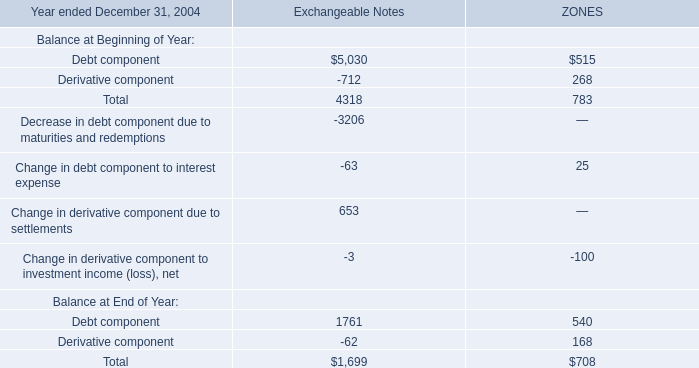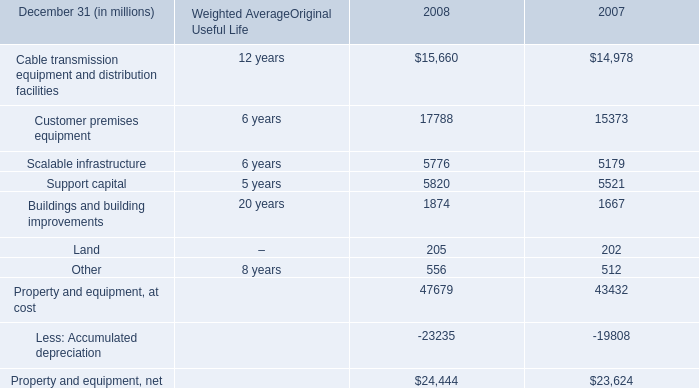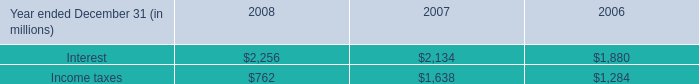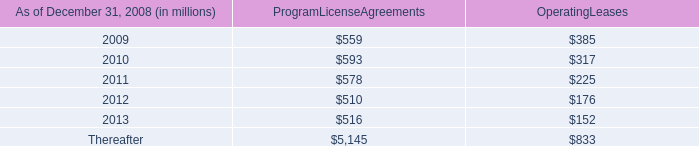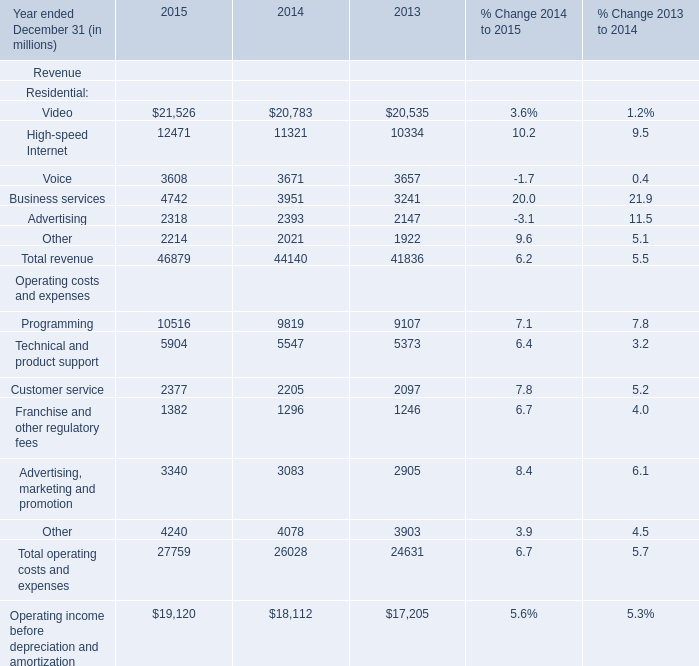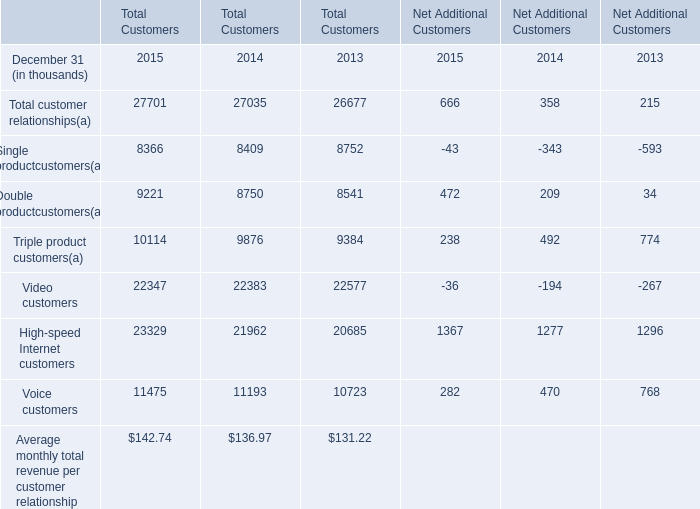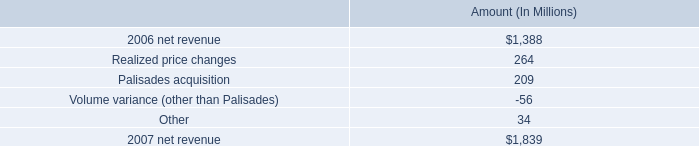what percent of 2017 net revenue did realized price changes account for? 
Computations: (264 / 1839)
Answer: 0.14356. 